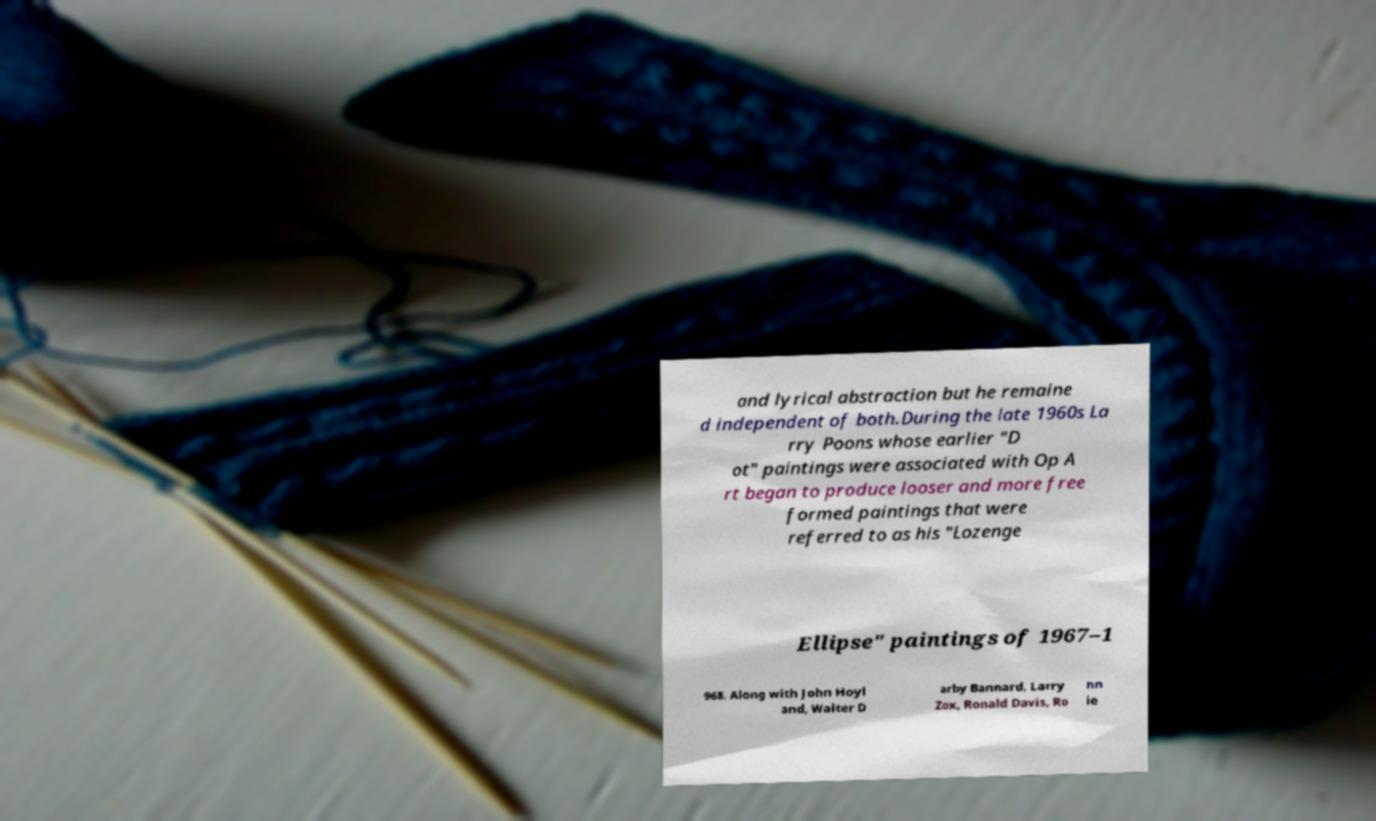Can you read and provide the text displayed in the image?This photo seems to have some interesting text. Can you extract and type it out for me? and lyrical abstraction but he remaine d independent of both.During the late 1960s La rry Poons whose earlier "D ot" paintings were associated with Op A rt began to produce looser and more free formed paintings that were referred to as his "Lozenge Ellipse" paintings of 1967–1 968. Along with John Hoyl and, Walter D arby Bannard, Larry Zox, Ronald Davis, Ro nn ie 